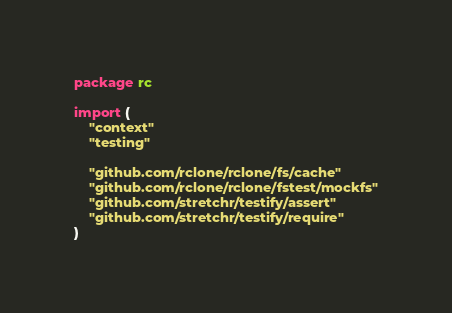<code> <loc_0><loc_0><loc_500><loc_500><_Go_>package rc

import (
	"context"
	"testing"

	"github.com/rclone/rclone/fs/cache"
	"github.com/rclone/rclone/fstest/mockfs"
	"github.com/stretchr/testify/assert"
	"github.com/stretchr/testify/require"
)
</code> 